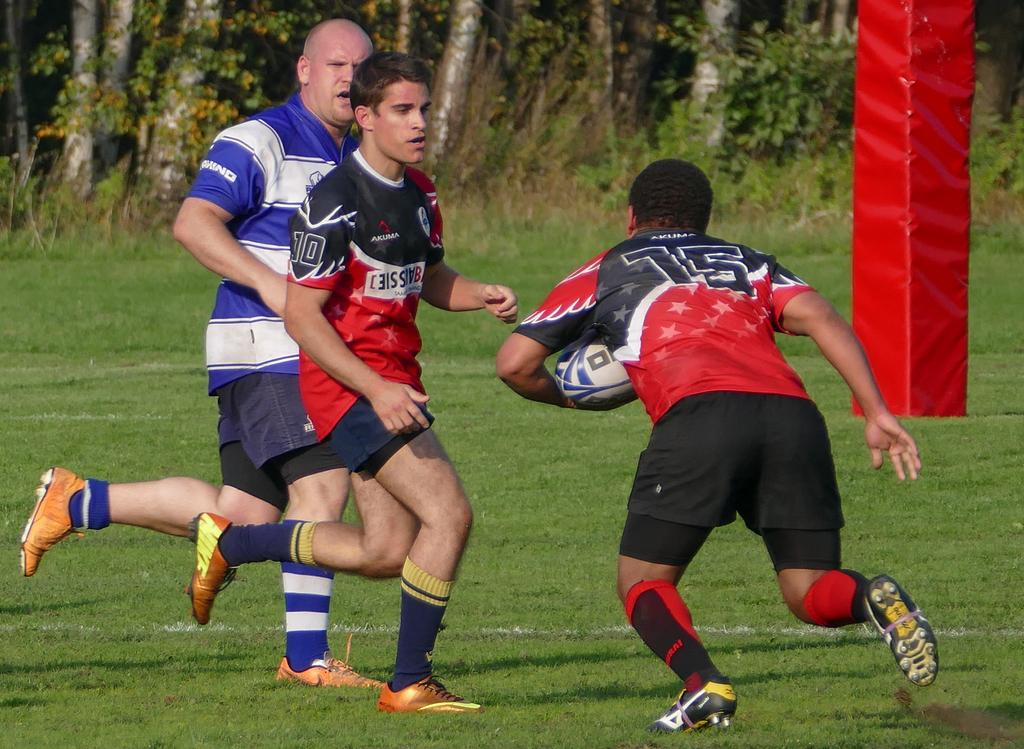How many people are in the image? There are three men in the image. What activity are the men engaged in? The men are playing football. What type of environment is depicted in the image? There are trees visible in the image, and there is a green field. What type of bone can be seen in the image? There is no bone present in the image; it features three men playing football on a green field with trees in the background. 